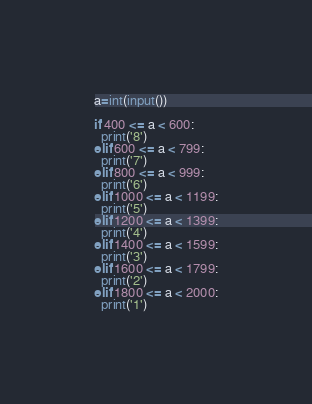<code> <loc_0><loc_0><loc_500><loc_500><_Python_>a=int(input())	

if 400 <= a < 600:
  print('8')
elif 600 <= a < 799:
  print('7')
elif 800 <= a < 999:
  print('6')
elif 1000 <= a < 1199:
  print('5')
elif 1200 <= a < 1399:
  print('4')
elif 1400 <= a < 1599:
  print('3')
elif 1600 <= a < 1799:
  print('2')
elif 1800 <= a < 2000:
  print('1')</code> 